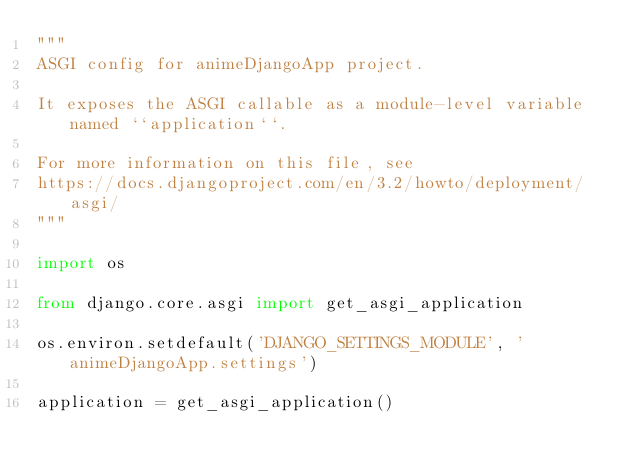Convert code to text. <code><loc_0><loc_0><loc_500><loc_500><_Python_>"""
ASGI config for animeDjangoApp project.

It exposes the ASGI callable as a module-level variable named ``application``.

For more information on this file, see
https://docs.djangoproject.com/en/3.2/howto/deployment/asgi/
"""

import os

from django.core.asgi import get_asgi_application

os.environ.setdefault('DJANGO_SETTINGS_MODULE', 'animeDjangoApp.settings')

application = get_asgi_application()
</code> 